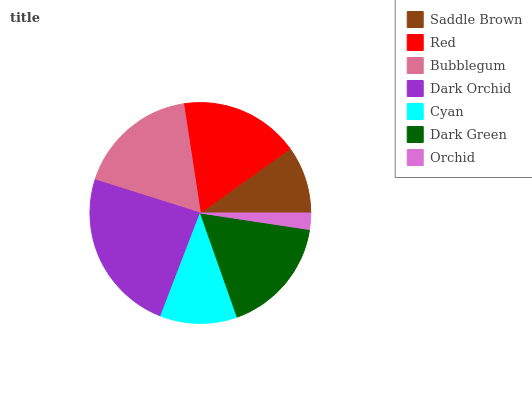Is Orchid the minimum?
Answer yes or no. Yes. Is Dark Orchid the maximum?
Answer yes or no. Yes. Is Red the minimum?
Answer yes or no. No. Is Red the maximum?
Answer yes or no. No. Is Red greater than Saddle Brown?
Answer yes or no. Yes. Is Saddle Brown less than Red?
Answer yes or no. Yes. Is Saddle Brown greater than Red?
Answer yes or no. No. Is Red less than Saddle Brown?
Answer yes or no. No. Is Dark Green the high median?
Answer yes or no. Yes. Is Dark Green the low median?
Answer yes or no. Yes. Is Bubblegum the high median?
Answer yes or no. No. Is Dark Orchid the low median?
Answer yes or no. No. 